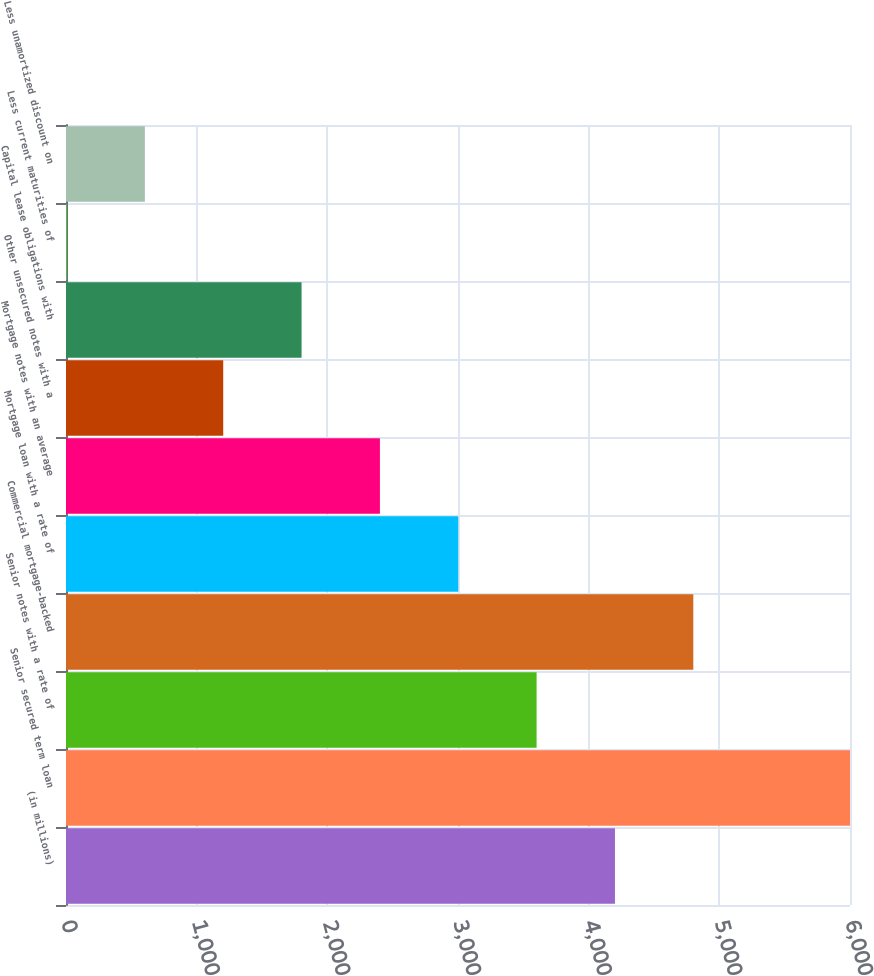<chart> <loc_0><loc_0><loc_500><loc_500><bar_chart><fcel>(in millions)<fcel>Senior secured term loan<fcel>Senior notes with a rate of<fcel>Commercial mortgage-backed<fcel>Mortgage loan with a rate of<fcel>Mortgage notes with an average<fcel>Other unsecured notes with a<fcel>Capital lease obligations with<fcel>Less current maturities of<fcel>Less unamortized discount on<nl><fcel>4201.2<fcel>6000<fcel>3601.6<fcel>4800.8<fcel>3002<fcel>2402.4<fcel>1203.2<fcel>1802.8<fcel>4<fcel>603.6<nl></chart> 